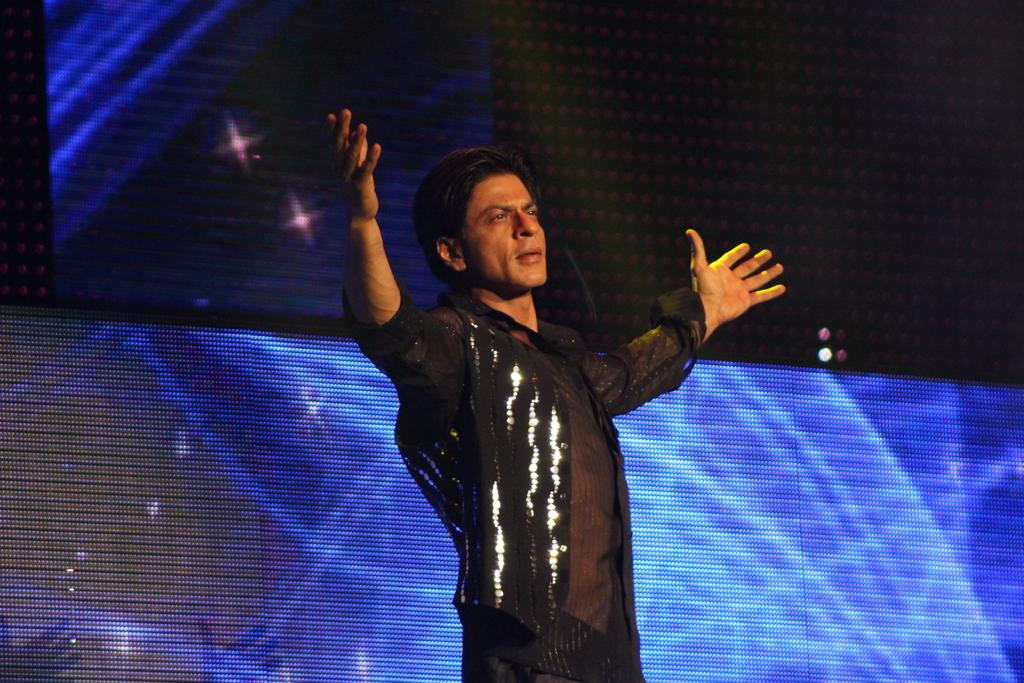Who is the main subject in the image? The main subject in the image is Shahrukh Khan. What is Shahrukh Khan doing in the image? Shahrukh Khan is performing an action in the image. What can be seen behind Shahrukh Khan in the image? There is an LED screen behind Shahrukh Khan. What type of butter is being used to create the winter scene on the moon in the image? There is no butter, winter scene, or moon present in the image; it features Shahrukh Khan performing an action with an LED screen behind him. 